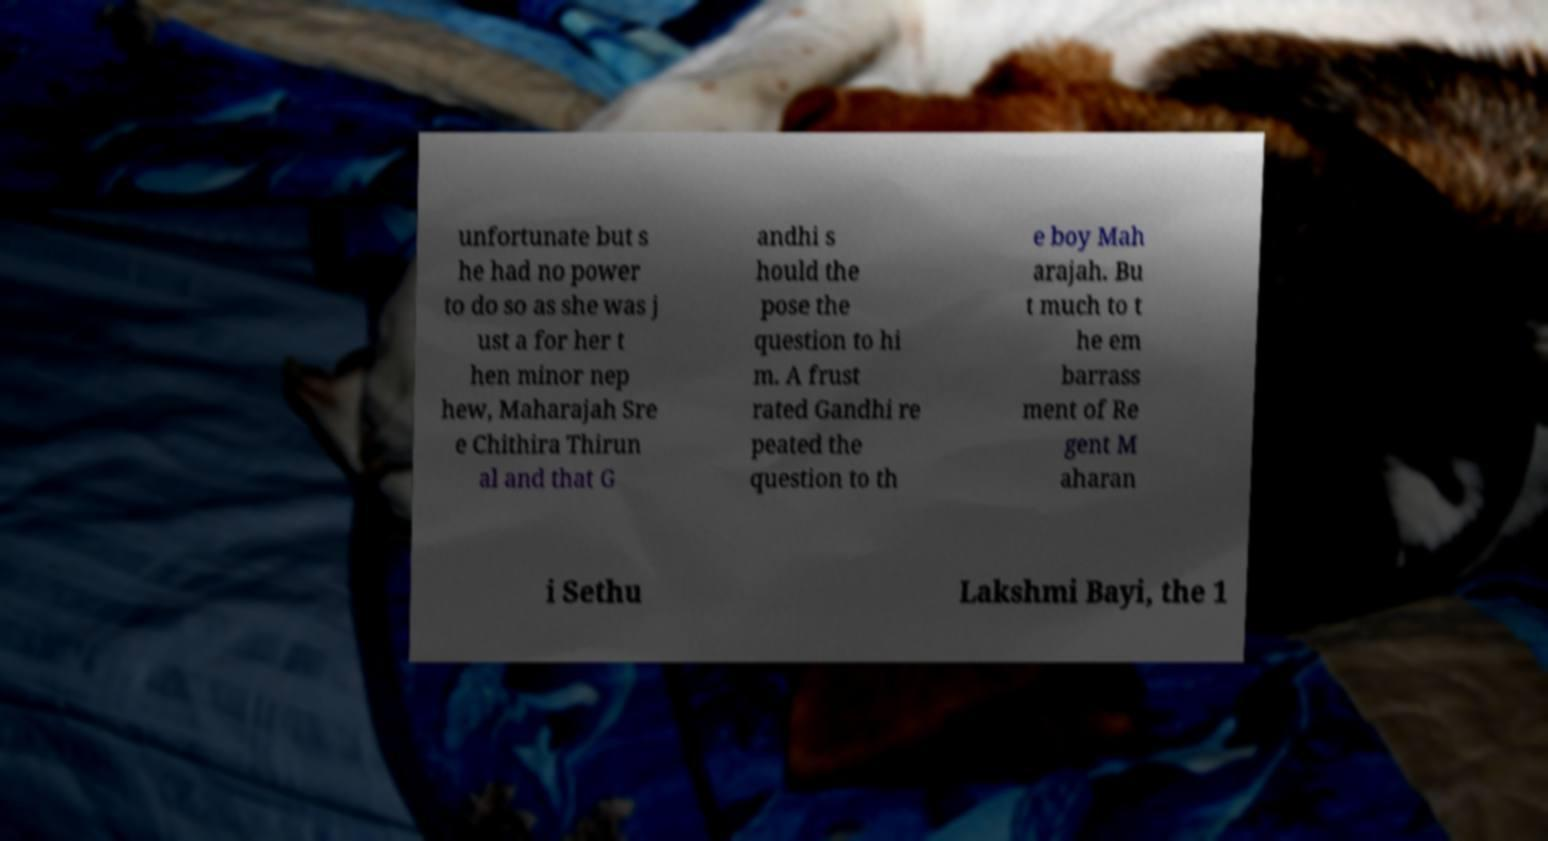There's text embedded in this image that I need extracted. Can you transcribe it verbatim? unfortunate but s he had no power to do so as she was j ust a for her t hen minor nep hew, Maharajah Sre e Chithira Thirun al and that G andhi s hould the pose the question to hi m. A frust rated Gandhi re peated the question to th e boy Mah arajah. Bu t much to t he em barrass ment of Re gent M aharan i Sethu Lakshmi Bayi, the 1 